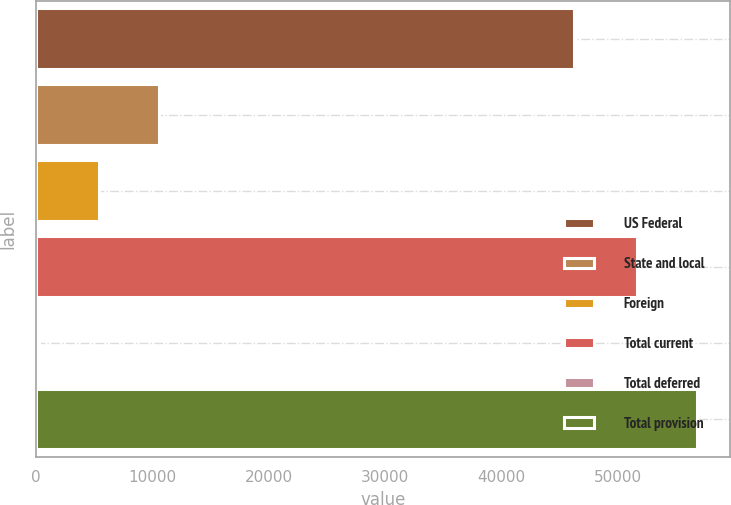Convert chart to OTSL. <chart><loc_0><loc_0><loc_500><loc_500><bar_chart><fcel>US Federal<fcel>State and local<fcel>Foreign<fcel>Total current<fcel>Total deferred<fcel>Total provision<nl><fcel>46225<fcel>10619.6<fcel>5455.8<fcel>51638<fcel>292<fcel>56801.8<nl></chart> 